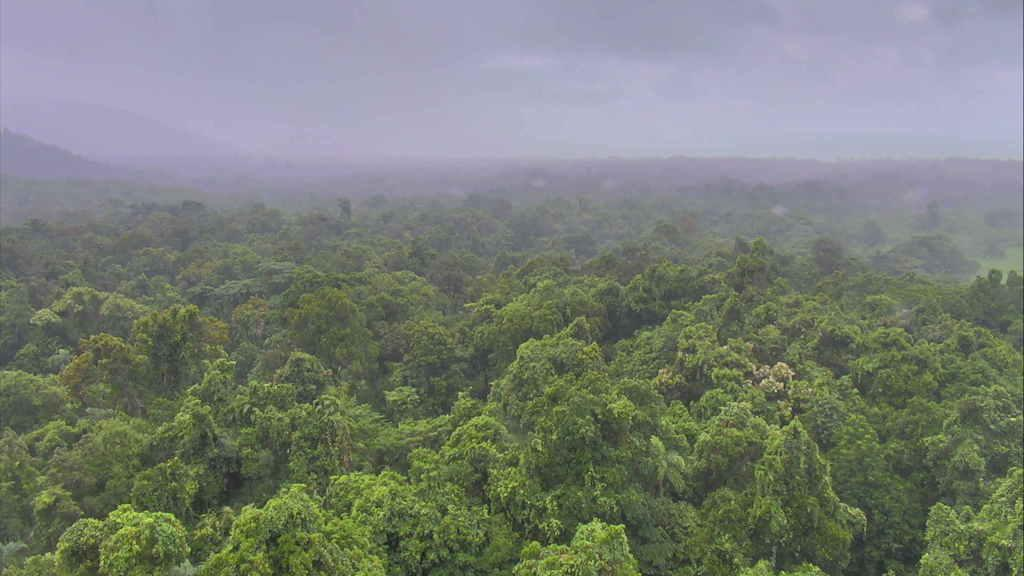What type of landscape is shown in the image? The image shows an aerial view of a forest. What can be observed about the vegetation in the forest? The forest is full of trees. What geographical features can be seen in the background of the image? There are hills visible in the background. How are the trees distributed in the image? Trees are present on and behind the hills. What is visible in the sky in the image? The sky is visible in the image, and clouds are present. Can you see any goldfish swimming in the image? There are no goldfish present in the image, as it is an aerial view of a forest with trees, hills, and clouds. How many waves can be counted in the image? There are no waves present in the image, as it is a landscape scene with a forest, hills, and sky. 